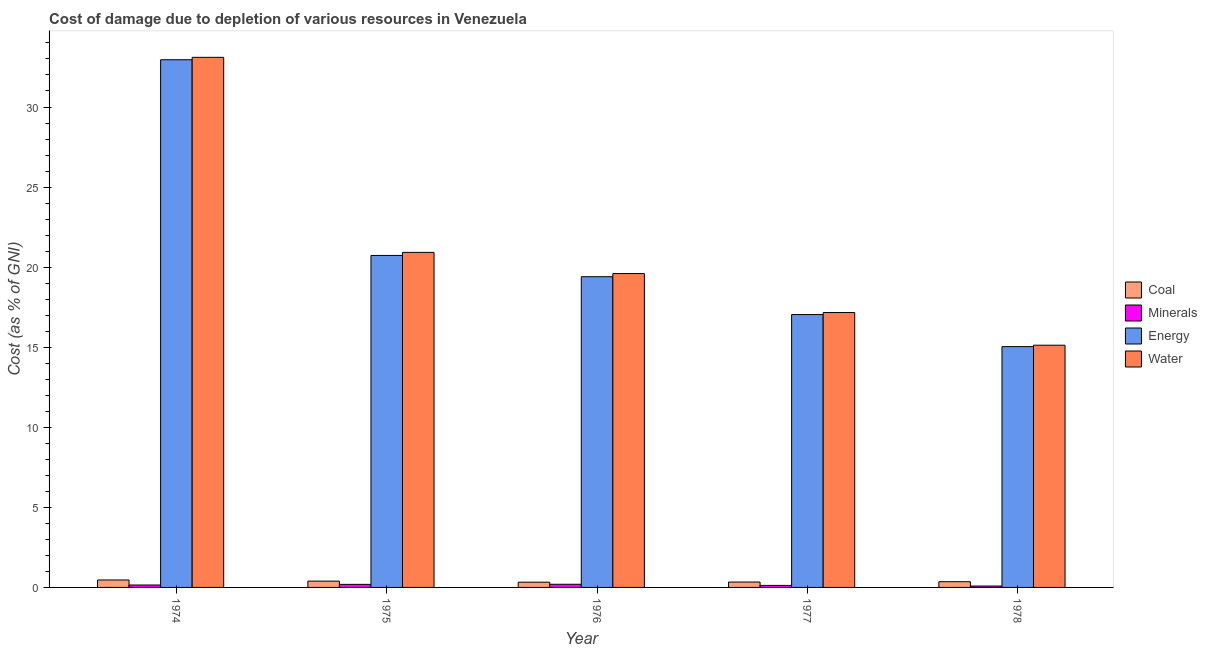How many different coloured bars are there?
Your answer should be very brief. 4. How many groups of bars are there?
Provide a succinct answer. 5. Are the number of bars per tick equal to the number of legend labels?
Offer a terse response. Yes. Are the number of bars on each tick of the X-axis equal?
Offer a terse response. Yes. How many bars are there on the 5th tick from the left?
Provide a short and direct response. 4. What is the label of the 1st group of bars from the left?
Provide a short and direct response. 1974. What is the cost of damage due to depletion of water in 1978?
Ensure brevity in your answer.  15.13. Across all years, what is the maximum cost of damage due to depletion of minerals?
Your response must be concise. 0.2. Across all years, what is the minimum cost of damage due to depletion of minerals?
Ensure brevity in your answer.  0.09. In which year was the cost of damage due to depletion of water maximum?
Ensure brevity in your answer.  1974. In which year was the cost of damage due to depletion of water minimum?
Your answer should be compact. 1978. What is the total cost of damage due to depletion of minerals in the graph?
Your answer should be very brief. 0.75. What is the difference between the cost of damage due to depletion of water in 1976 and that in 1978?
Your response must be concise. 4.47. What is the difference between the cost of damage due to depletion of coal in 1974 and the cost of damage due to depletion of minerals in 1978?
Your answer should be very brief. 0.11. What is the average cost of damage due to depletion of water per year?
Keep it short and to the point. 21.18. In the year 1974, what is the difference between the cost of damage due to depletion of minerals and cost of damage due to depletion of energy?
Ensure brevity in your answer.  0. What is the ratio of the cost of damage due to depletion of energy in 1976 to that in 1978?
Give a very brief answer. 1.29. Is the cost of damage due to depletion of coal in 1974 less than that in 1975?
Provide a short and direct response. No. What is the difference between the highest and the second highest cost of damage due to depletion of water?
Your response must be concise. 12.18. What is the difference between the highest and the lowest cost of damage due to depletion of water?
Offer a very short reply. 17.98. Is the sum of the cost of damage due to depletion of coal in 1975 and 1976 greater than the maximum cost of damage due to depletion of water across all years?
Give a very brief answer. Yes. What does the 2nd bar from the left in 1976 represents?
Offer a terse response. Minerals. What does the 3rd bar from the right in 1975 represents?
Provide a succinct answer. Minerals. Is it the case that in every year, the sum of the cost of damage due to depletion of coal and cost of damage due to depletion of minerals is greater than the cost of damage due to depletion of energy?
Your answer should be compact. No. How many bars are there?
Offer a very short reply. 20. Are all the bars in the graph horizontal?
Offer a terse response. No. How many years are there in the graph?
Make the answer very short. 5. Where does the legend appear in the graph?
Make the answer very short. Center right. How are the legend labels stacked?
Your response must be concise. Vertical. What is the title of the graph?
Provide a short and direct response. Cost of damage due to depletion of various resources in Venezuela . Does "Primary education" appear as one of the legend labels in the graph?
Make the answer very short. No. What is the label or title of the Y-axis?
Provide a succinct answer. Cost (as % of GNI). What is the Cost (as % of GNI) in Coal in 1974?
Make the answer very short. 0.47. What is the Cost (as % of GNI) in Minerals in 1974?
Offer a terse response. 0.15. What is the Cost (as % of GNI) in Energy in 1974?
Offer a very short reply. 32.95. What is the Cost (as % of GNI) in Water in 1974?
Make the answer very short. 33.1. What is the Cost (as % of GNI) in Coal in 1975?
Give a very brief answer. 0.39. What is the Cost (as % of GNI) in Minerals in 1975?
Make the answer very short. 0.19. What is the Cost (as % of GNI) in Energy in 1975?
Provide a succinct answer. 20.73. What is the Cost (as % of GNI) in Water in 1975?
Offer a very short reply. 20.92. What is the Cost (as % of GNI) in Coal in 1976?
Offer a very short reply. 0.33. What is the Cost (as % of GNI) of Minerals in 1976?
Give a very brief answer. 0.2. What is the Cost (as % of GNI) of Energy in 1976?
Provide a short and direct response. 19.4. What is the Cost (as % of GNI) of Water in 1976?
Your answer should be very brief. 19.6. What is the Cost (as % of GNI) of Coal in 1977?
Give a very brief answer. 0.34. What is the Cost (as % of GNI) in Minerals in 1977?
Give a very brief answer. 0.13. What is the Cost (as % of GNI) in Energy in 1977?
Provide a succinct answer. 17.04. What is the Cost (as % of GNI) in Water in 1977?
Offer a terse response. 17.17. What is the Cost (as % of GNI) in Coal in 1978?
Give a very brief answer. 0.36. What is the Cost (as % of GNI) of Minerals in 1978?
Give a very brief answer. 0.09. What is the Cost (as % of GNI) in Energy in 1978?
Keep it short and to the point. 15.04. What is the Cost (as % of GNI) in Water in 1978?
Offer a very short reply. 15.13. Across all years, what is the maximum Cost (as % of GNI) of Coal?
Make the answer very short. 0.47. Across all years, what is the maximum Cost (as % of GNI) of Minerals?
Your answer should be very brief. 0.2. Across all years, what is the maximum Cost (as % of GNI) in Energy?
Offer a very short reply. 32.95. Across all years, what is the maximum Cost (as % of GNI) in Water?
Your answer should be compact. 33.1. Across all years, what is the minimum Cost (as % of GNI) of Coal?
Provide a short and direct response. 0.33. Across all years, what is the minimum Cost (as % of GNI) in Minerals?
Your response must be concise. 0.09. Across all years, what is the minimum Cost (as % of GNI) in Energy?
Keep it short and to the point. 15.04. Across all years, what is the minimum Cost (as % of GNI) of Water?
Offer a terse response. 15.13. What is the total Cost (as % of GNI) of Coal in the graph?
Offer a very short reply. 1.88. What is the total Cost (as % of GNI) in Minerals in the graph?
Offer a terse response. 0.75. What is the total Cost (as % of GNI) of Energy in the graph?
Your response must be concise. 105.16. What is the total Cost (as % of GNI) in Water in the graph?
Make the answer very short. 105.91. What is the difference between the Cost (as % of GNI) of Coal in 1974 and that in 1975?
Provide a succinct answer. 0.07. What is the difference between the Cost (as % of GNI) of Minerals in 1974 and that in 1975?
Keep it short and to the point. -0.04. What is the difference between the Cost (as % of GNI) in Energy in 1974 and that in 1975?
Provide a short and direct response. 12.22. What is the difference between the Cost (as % of GNI) in Water in 1974 and that in 1975?
Your answer should be very brief. 12.18. What is the difference between the Cost (as % of GNI) in Coal in 1974 and that in 1976?
Offer a terse response. 0.14. What is the difference between the Cost (as % of GNI) of Minerals in 1974 and that in 1976?
Your answer should be very brief. -0.05. What is the difference between the Cost (as % of GNI) of Energy in 1974 and that in 1976?
Ensure brevity in your answer.  13.55. What is the difference between the Cost (as % of GNI) in Water in 1974 and that in 1976?
Keep it short and to the point. 13.5. What is the difference between the Cost (as % of GNI) in Coal in 1974 and that in 1977?
Ensure brevity in your answer.  0.13. What is the difference between the Cost (as % of GNI) in Minerals in 1974 and that in 1977?
Provide a short and direct response. 0.02. What is the difference between the Cost (as % of GNI) in Energy in 1974 and that in 1977?
Your response must be concise. 15.91. What is the difference between the Cost (as % of GNI) of Water in 1974 and that in 1977?
Keep it short and to the point. 15.94. What is the difference between the Cost (as % of GNI) in Coal in 1974 and that in 1978?
Your answer should be very brief. 0.11. What is the difference between the Cost (as % of GNI) of Minerals in 1974 and that in 1978?
Offer a terse response. 0.06. What is the difference between the Cost (as % of GNI) of Energy in 1974 and that in 1978?
Ensure brevity in your answer.  17.91. What is the difference between the Cost (as % of GNI) in Water in 1974 and that in 1978?
Make the answer very short. 17.98. What is the difference between the Cost (as % of GNI) in Coal in 1975 and that in 1976?
Give a very brief answer. 0.07. What is the difference between the Cost (as % of GNI) in Minerals in 1975 and that in 1976?
Give a very brief answer. -0.01. What is the difference between the Cost (as % of GNI) of Energy in 1975 and that in 1976?
Offer a terse response. 1.33. What is the difference between the Cost (as % of GNI) of Water in 1975 and that in 1976?
Give a very brief answer. 1.32. What is the difference between the Cost (as % of GNI) of Coal in 1975 and that in 1977?
Provide a short and direct response. 0.06. What is the difference between the Cost (as % of GNI) of Minerals in 1975 and that in 1977?
Make the answer very short. 0.06. What is the difference between the Cost (as % of GNI) in Energy in 1975 and that in 1977?
Give a very brief answer. 3.69. What is the difference between the Cost (as % of GNI) in Water in 1975 and that in 1977?
Your response must be concise. 3.76. What is the difference between the Cost (as % of GNI) in Coal in 1975 and that in 1978?
Keep it short and to the point. 0.04. What is the difference between the Cost (as % of GNI) in Minerals in 1975 and that in 1978?
Your answer should be very brief. 0.1. What is the difference between the Cost (as % of GNI) of Energy in 1975 and that in 1978?
Give a very brief answer. 5.69. What is the difference between the Cost (as % of GNI) of Water in 1975 and that in 1978?
Your answer should be very brief. 5.8. What is the difference between the Cost (as % of GNI) of Coal in 1976 and that in 1977?
Give a very brief answer. -0.01. What is the difference between the Cost (as % of GNI) of Minerals in 1976 and that in 1977?
Provide a short and direct response. 0.07. What is the difference between the Cost (as % of GNI) in Energy in 1976 and that in 1977?
Give a very brief answer. 2.36. What is the difference between the Cost (as % of GNI) in Water in 1976 and that in 1977?
Keep it short and to the point. 2.43. What is the difference between the Cost (as % of GNI) in Coal in 1976 and that in 1978?
Ensure brevity in your answer.  -0.03. What is the difference between the Cost (as % of GNI) of Minerals in 1976 and that in 1978?
Offer a very short reply. 0.11. What is the difference between the Cost (as % of GNI) in Energy in 1976 and that in 1978?
Offer a terse response. 4.37. What is the difference between the Cost (as % of GNI) of Water in 1976 and that in 1978?
Your answer should be very brief. 4.47. What is the difference between the Cost (as % of GNI) in Coal in 1977 and that in 1978?
Your response must be concise. -0.02. What is the difference between the Cost (as % of GNI) of Minerals in 1977 and that in 1978?
Provide a short and direct response. 0.04. What is the difference between the Cost (as % of GNI) in Energy in 1977 and that in 1978?
Your response must be concise. 2. What is the difference between the Cost (as % of GNI) in Water in 1977 and that in 1978?
Give a very brief answer. 2.04. What is the difference between the Cost (as % of GNI) of Coal in 1974 and the Cost (as % of GNI) of Minerals in 1975?
Give a very brief answer. 0.27. What is the difference between the Cost (as % of GNI) of Coal in 1974 and the Cost (as % of GNI) of Energy in 1975?
Provide a succinct answer. -20.27. What is the difference between the Cost (as % of GNI) in Coal in 1974 and the Cost (as % of GNI) in Water in 1975?
Provide a succinct answer. -20.46. What is the difference between the Cost (as % of GNI) of Minerals in 1974 and the Cost (as % of GNI) of Energy in 1975?
Provide a succinct answer. -20.58. What is the difference between the Cost (as % of GNI) in Minerals in 1974 and the Cost (as % of GNI) in Water in 1975?
Your answer should be compact. -20.77. What is the difference between the Cost (as % of GNI) in Energy in 1974 and the Cost (as % of GNI) in Water in 1975?
Provide a succinct answer. 12.03. What is the difference between the Cost (as % of GNI) of Coal in 1974 and the Cost (as % of GNI) of Minerals in 1976?
Offer a very short reply. 0.27. What is the difference between the Cost (as % of GNI) in Coal in 1974 and the Cost (as % of GNI) in Energy in 1976?
Provide a short and direct response. -18.94. What is the difference between the Cost (as % of GNI) of Coal in 1974 and the Cost (as % of GNI) of Water in 1976?
Ensure brevity in your answer.  -19.13. What is the difference between the Cost (as % of GNI) of Minerals in 1974 and the Cost (as % of GNI) of Energy in 1976?
Ensure brevity in your answer.  -19.25. What is the difference between the Cost (as % of GNI) of Minerals in 1974 and the Cost (as % of GNI) of Water in 1976?
Offer a terse response. -19.45. What is the difference between the Cost (as % of GNI) of Energy in 1974 and the Cost (as % of GNI) of Water in 1976?
Give a very brief answer. 13.35. What is the difference between the Cost (as % of GNI) in Coal in 1974 and the Cost (as % of GNI) in Minerals in 1977?
Keep it short and to the point. 0.34. What is the difference between the Cost (as % of GNI) of Coal in 1974 and the Cost (as % of GNI) of Energy in 1977?
Ensure brevity in your answer.  -16.57. What is the difference between the Cost (as % of GNI) in Coal in 1974 and the Cost (as % of GNI) in Water in 1977?
Provide a short and direct response. -16.7. What is the difference between the Cost (as % of GNI) in Minerals in 1974 and the Cost (as % of GNI) in Energy in 1977?
Your response must be concise. -16.89. What is the difference between the Cost (as % of GNI) of Minerals in 1974 and the Cost (as % of GNI) of Water in 1977?
Ensure brevity in your answer.  -17.01. What is the difference between the Cost (as % of GNI) in Energy in 1974 and the Cost (as % of GNI) in Water in 1977?
Keep it short and to the point. 15.79. What is the difference between the Cost (as % of GNI) in Coal in 1974 and the Cost (as % of GNI) in Minerals in 1978?
Your answer should be very brief. 0.38. What is the difference between the Cost (as % of GNI) in Coal in 1974 and the Cost (as % of GNI) in Energy in 1978?
Make the answer very short. -14.57. What is the difference between the Cost (as % of GNI) in Coal in 1974 and the Cost (as % of GNI) in Water in 1978?
Ensure brevity in your answer.  -14.66. What is the difference between the Cost (as % of GNI) in Minerals in 1974 and the Cost (as % of GNI) in Energy in 1978?
Offer a very short reply. -14.89. What is the difference between the Cost (as % of GNI) in Minerals in 1974 and the Cost (as % of GNI) in Water in 1978?
Offer a very short reply. -14.97. What is the difference between the Cost (as % of GNI) of Energy in 1974 and the Cost (as % of GNI) of Water in 1978?
Your response must be concise. 17.83. What is the difference between the Cost (as % of GNI) in Coal in 1975 and the Cost (as % of GNI) in Minerals in 1976?
Make the answer very short. 0.2. What is the difference between the Cost (as % of GNI) of Coal in 1975 and the Cost (as % of GNI) of Energy in 1976?
Provide a short and direct response. -19.01. What is the difference between the Cost (as % of GNI) in Coal in 1975 and the Cost (as % of GNI) in Water in 1976?
Give a very brief answer. -19.21. What is the difference between the Cost (as % of GNI) of Minerals in 1975 and the Cost (as % of GNI) of Energy in 1976?
Provide a succinct answer. -19.21. What is the difference between the Cost (as % of GNI) in Minerals in 1975 and the Cost (as % of GNI) in Water in 1976?
Your answer should be very brief. -19.41. What is the difference between the Cost (as % of GNI) of Energy in 1975 and the Cost (as % of GNI) of Water in 1976?
Your answer should be compact. 1.13. What is the difference between the Cost (as % of GNI) in Coal in 1975 and the Cost (as % of GNI) in Minerals in 1977?
Provide a short and direct response. 0.27. What is the difference between the Cost (as % of GNI) in Coal in 1975 and the Cost (as % of GNI) in Energy in 1977?
Offer a terse response. -16.64. What is the difference between the Cost (as % of GNI) in Coal in 1975 and the Cost (as % of GNI) in Water in 1977?
Your answer should be very brief. -16.77. What is the difference between the Cost (as % of GNI) of Minerals in 1975 and the Cost (as % of GNI) of Energy in 1977?
Ensure brevity in your answer.  -16.85. What is the difference between the Cost (as % of GNI) of Minerals in 1975 and the Cost (as % of GNI) of Water in 1977?
Provide a succinct answer. -16.97. What is the difference between the Cost (as % of GNI) in Energy in 1975 and the Cost (as % of GNI) in Water in 1977?
Your answer should be compact. 3.57. What is the difference between the Cost (as % of GNI) of Coal in 1975 and the Cost (as % of GNI) of Minerals in 1978?
Keep it short and to the point. 0.31. What is the difference between the Cost (as % of GNI) of Coal in 1975 and the Cost (as % of GNI) of Energy in 1978?
Your answer should be very brief. -14.64. What is the difference between the Cost (as % of GNI) of Coal in 1975 and the Cost (as % of GNI) of Water in 1978?
Offer a very short reply. -14.73. What is the difference between the Cost (as % of GNI) in Minerals in 1975 and the Cost (as % of GNI) in Energy in 1978?
Offer a terse response. -14.85. What is the difference between the Cost (as % of GNI) in Minerals in 1975 and the Cost (as % of GNI) in Water in 1978?
Keep it short and to the point. -14.93. What is the difference between the Cost (as % of GNI) of Energy in 1975 and the Cost (as % of GNI) of Water in 1978?
Provide a succinct answer. 5.61. What is the difference between the Cost (as % of GNI) of Coal in 1976 and the Cost (as % of GNI) of Minerals in 1977?
Ensure brevity in your answer.  0.2. What is the difference between the Cost (as % of GNI) of Coal in 1976 and the Cost (as % of GNI) of Energy in 1977?
Provide a short and direct response. -16.71. What is the difference between the Cost (as % of GNI) of Coal in 1976 and the Cost (as % of GNI) of Water in 1977?
Offer a very short reply. -16.84. What is the difference between the Cost (as % of GNI) of Minerals in 1976 and the Cost (as % of GNI) of Energy in 1977?
Keep it short and to the point. -16.84. What is the difference between the Cost (as % of GNI) in Minerals in 1976 and the Cost (as % of GNI) in Water in 1977?
Provide a short and direct response. -16.97. What is the difference between the Cost (as % of GNI) in Energy in 1976 and the Cost (as % of GNI) in Water in 1977?
Ensure brevity in your answer.  2.24. What is the difference between the Cost (as % of GNI) in Coal in 1976 and the Cost (as % of GNI) in Minerals in 1978?
Ensure brevity in your answer.  0.24. What is the difference between the Cost (as % of GNI) of Coal in 1976 and the Cost (as % of GNI) of Energy in 1978?
Ensure brevity in your answer.  -14.71. What is the difference between the Cost (as % of GNI) of Coal in 1976 and the Cost (as % of GNI) of Water in 1978?
Give a very brief answer. -14.8. What is the difference between the Cost (as % of GNI) of Minerals in 1976 and the Cost (as % of GNI) of Energy in 1978?
Keep it short and to the point. -14.84. What is the difference between the Cost (as % of GNI) in Minerals in 1976 and the Cost (as % of GNI) in Water in 1978?
Your answer should be compact. -14.93. What is the difference between the Cost (as % of GNI) of Energy in 1976 and the Cost (as % of GNI) of Water in 1978?
Provide a succinct answer. 4.28. What is the difference between the Cost (as % of GNI) of Coal in 1977 and the Cost (as % of GNI) of Minerals in 1978?
Give a very brief answer. 0.25. What is the difference between the Cost (as % of GNI) of Coal in 1977 and the Cost (as % of GNI) of Energy in 1978?
Provide a succinct answer. -14.7. What is the difference between the Cost (as % of GNI) of Coal in 1977 and the Cost (as % of GNI) of Water in 1978?
Ensure brevity in your answer.  -14.79. What is the difference between the Cost (as % of GNI) in Minerals in 1977 and the Cost (as % of GNI) in Energy in 1978?
Offer a terse response. -14.91. What is the difference between the Cost (as % of GNI) in Minerals in 1977 and the Cost (as % of GNI) in Water in 1978?
Make the answer very short. -15. What is the difference between the Cost (as % of GNI) of Energy in 1977 and the Cost (as % of GNI) of Water in 1978?
Provide a short and direct response. 1.91. What is the average Cost (as % of GNI) in Coal per year?
Your answer should be very brief. 0.38. What is the average Cost (as % of GNI) in Minerals per year?
Ensure brevity in your answer.  0.15. What is the average Cost (as % of GNI) in Energy per year?
Ensure brevity in your answer.  21.03. What is the average Cost (as % of GNI) of Water per year?
Ensure brevity in your answer.  21.18. In the year 1974, what is the difference between the Cost (as % of GNI) of Coal and Cost (as % of GNI) of Minerals?
Provide a short and direct response. 0.31. In the year 1974, what is the difference between the Cost (as % of GNI) in Coal and Cost (as % of GNI) in Energy?
Ensure brevity in your answer.  -32.49. In the year 1974, what is the difference between the Cost (as % of GNI) in Coal and Cost (as % of GNI) in Water?
Provide a succinct answer. -32.64. In the year 1974, what is the difference between the Cost (as % of GNI) of Minerals and Cost (as % of GNI) of Energy?
Give a very brief answer. -32.8. In the year 1974, what is the difference between the Cost (as % of GNI) of Minerals and Cost (as % of GNI) of Water?
Your answer should be compact. -32.95. In the year 1974, what is the difference between the Cost (as % of GNI) of Energy and Cost (as % of GNI) of Water?
Make the answer very short. -0.15. In the year 1975, what is the difference between the Cost (as % of GNI) in Coal and Cost (as % of GNI) in Minerals?
Ensure brevity in your answer.  0.2. In the year 1975, what is the difference between the Cost (as % of GNI) of Coal and Cost (as % of GNI) of Energy?
Offer a terse response. -20.34. In the year 1975, what is the difference between the Cost (as % of GNI) in Coal and Cost (as % of GNI) in Water?
Your response must be concise. -20.53. In the year 1975, what is the difference between the Cost (as % of GNI) in Minerals and Cost (as % of GNI) in Energy?
Offer a terse response. -20.54. In the year 1975, what is the difference between the Cost (as % of GNI) in Minerals and Cost (as % of GNI) in Water?
Ensure brevity in your answer.  -20.73. In the year 1975, what is the difference between the Cost (as % of GNI) in Energy and Cost (as % of GNI) in Water?
Make the answer very short. -0.19. In the year 1976, what is the difference between the Cost (as % of GNI) in Coal and Cost (as % of GNI) in Minerals?
Your response must be concise. 0.13. In the year 1976, what is the difference between the Cost (as % of GNI) of Coal and Cost (as % of GNI) of Energy?
Provide a succinct answer. -19.08. In the year 1976, what is the difference between the Cost (as % of GNI) of Coal and Cost (as % of GNI) of Water?
Your answer should be compact. -19.27. In the year 1976, what is the difference between the Cost (as % of GNI) of Minerals and Cost (as % of GNI) of Energy?
Offer a very short reply. -19.21. In the year 1976, what is the difference between the Cost (as % of GNI) in Minerals and Cost (as % of GNI) in Water?
Provide a succinct answer. -19.4. In the year 1976, what is the difference between the Cost (as % of GNI) in Energy and Cost (as % of GNI) in Water?
Your answer should be very brief. -0.2. In the year 1977, what is the difference between the Cost (as % of GNI) of Coal and Cost (as % of GNI) of Minerals?
Your response must be concise. 0.21. In the year 1977, what is the difference between the Cost (as % of GNI) of Coal and Cost (as % of GNI) of Energy?
Give a very brief answer. -16.7. In the year 1977, what is the difference between the Cost (as % of GNI) in Coal and Cost (as % of GNI) in Water?
Give a very brief answer. -16.83. In the year 1977, what is the difference between the Cost (as % of GNI) in Minerals and Cost (as % of GNI) in Energy?
Offer a terse response. -16.91. In the year 1977, what is the difference between the Cost (as % of GNI) in Minerals and Cost (as % of GNI) in Water?
Provide a succinct answer. -17.04. In the year 1977, what is the difference between the Cost (as % of GNI) in Energy and Cost (as % of GNI) in Water?
Provide a short and direct response. -0.13. In the year 1978, what is the difference between the Cost (as % of GNI) of Coal and Cost (as % of GNI) of Minerals?
Your answer should be compact. 0.27. In the year 1978, what is the difference between the Cost (as % of GNI) in Coal and Cost (as % of GNI) in Energy?
Provide a succinct answer. -14.68. In the year 1978, what is the difference between the Cost (as % of GNI) of Coal and Cost (as % of GNI) of Water?
Keep it short and to the point. -14.77. In the year 1978, what is the difference between the Cost (as % of GNI) in Minerals and Cost (as % of GNI) in Energy?
Provide a short and direct response. -14.95. In the year 1978, what is the difference between the Cost (as % of GNI) of Minerals and Cost (as % of GNI) of Water?
Make the answer very short. -15.04. In the year 1978, what is the difference between the Cost (as % of GNI) of Energy and Cost (as % of GNI) of Water?
Provide a short and direct response. -0.09. What is the ratio of the Cost (as % of GNI) of Coal in 1974 to that in 1975?
Your answer should be very brief. 1.18. What is the ratio of the Cost (as % of GNI) in Minerals in 1974 to that in 1975?
Your answer should be compact. 0.79. What is the ratio of the Cost (as % of GNI) of Energy in 1974 to that in 1975?
Keep it short and to the point. 1.59. What is the ratio of the Cost (as % of GNI) in Water in 1974 to that in 1975?
Offer a very short reply. 1.58. What is the ratio of the Cost (as % of GNI) of Coal in 1974 to that in 1976?
Your answer should be very brief. 1.42. What is the ratio of the Cost (as % of GNI) in Minerals in 1974 to that in 1976?
Offer a terse response. 0.77. What is the ratio of the Cost (as % of GNI) in Energy in 1974 to that in 1976?
Your answer should be very brief. 1.7. What is the ratio of the Cost (as % of GNI) of Water in 1974 to that in 1976?
Your answer should be very brief. 1.69. What is the ratio of the Cost (as % of GNI) in Coal in 1974 to that in 1977?
Offer a very short reply. 1.39. What is the ratio of the Cost (as % of GNI) of Minerals in 1974 to that in 1977?
Ensure brevity in your answer.  1.19. What is the ratio of the Cost (as % of GNI) in Energy in 1974 to that in 1977?
Your response must be concise. 1.93. What is the ratio of the Cost (as % of GNI) of Water in 1974 to that in 1977?
Your answer should be very brief. 1.93. What is the ratio of the Cost (as % of GNI) of Coal in 1974 to that in 1978?
Make the answer very short. 1.3. What is the ratio of the Cost (as % of GNI) in Minerals in 1974 to that in 1978?
Offer a very short reply. 1.72. What is the ratio of the Cost (as % of GNI) in Energy in 1974 to that in 1978?
Your response must be concise. 2.19. What is the ratio of the Cost (as % of GNI) in Water in 1974 to that in 1978?
Offer a terse response. 2.19. What is the ratio of the Cost (as % of GNI) of Coal in 1975 to that in 1976?
Your answer should be very brief. 1.21. What is the ratio of the Cost (as % of GNI) of Minerals in 1975 to that in 1976?
Offer a terse response. 0.97. What is the ratio of the Cost (as % of GNI) in Energy in 1975 to that in 1976?
Your response must be concise. 1.07. What is the ratio of the Cost (as % of GNI) in Water in 1975 to that in 1976?
Offer a very short reply. 1.07. What is the ratio of the Cost (as % of GNI) in Coal in 1975 to that in 1977?
Your response must be concise. 1.18. What is the ratio of the Cost (as % of GNI) of Minerals in 1975 to that in 1977?
Offer a terse response. 1.51. What is the ratio of the Cost (as % of GNI) in Energy in 1975 to that in 1977?
Your response must be concise. 1.22. What is the ratio of the Cost (as % of GNI) of Water in 1975 to that in 1977?
Offer a terse response. 1.22. What is the ratio of the Cost (as % of GNI) of Coal in 1975 to that in 1978?
Give a very brief answer. 1.11. What is the ratio of the Cost (as % of GNI) in Minerals in 1975 to that in 1978?
Your answer should be very brief. 2.18. What is the ratio of the Cost (as % of GNI) of Energy in 1975 to that in 1978?
Give a very brief answer. 1.38. What is the ratio of the Cost (as % of GNI) in Water in 1975 to that in 1978?
Your answer should be compact. 1.38. What is the ratio of the Cost (as % of GNI) of Coal in 1976 to that in 1977?
Ensure brevity in your answer.  0.97. What is the ratio of the Cost (as % of GNI) in Minerals in 1976 to that in 1977?
Your answer should be very brief. 1.56. What is the ratio of the Cost (as % of GNI) in Energy in 1976 to that in 1977?
Keep it short and to the point. 1.14. What is the ratio of the Cost (as % of GNI) of Water in 1976 to that in 1977?
Ensure brevity in your answer.  1.14. What is the ratio of the Cost (as % of GNI) in Coal in 1976 to that in 1978?
Offer a terse response. 0.92. What is the ratio of the Cost (as % of GNI) of Minerals in 1976 to that in 1978?
Ensure brevity in your answer.  2.24. What is the ratio of the Cost (as % of GNI) in Energy in 1976 to that in 1978?
Your answer should be very brief. 1.29. What is the ratio of the Cost (as % of GNI) in Water in 1976 to that in 1978?
Your response must be concise. 1.3. What is the ratio of the Cost (as % of GNI) of Coal in 1977 to that in 1978?
Provide a succinct answer. 0.94. What is the ratio of the Cost (as % of GNI) in Minerals in 1977 to that in 1978?
Provide a short and direct response. 1.44. What is the ratio of the Cost (as % of GNI) in Energy in 1977 to that in 1978?
Provide a short and direct response. 1.13. What is the ratio of the Cost (as % of GNI) of Water in 1977 to that in 1978?
Make the answer very short. 1.13. What is the difference between the highest and the second highest Cost (as % of GNI) of Coal?
Your response must be concise. 0.07. What is the difference between the highest and the second highest Cost (as % of GNI) in Minerals?
Your response must be concise. 0.01. What is the difference between the highest and the second highest Cost (as % of GNI) of Energy?
Make the answer very short. 12.22. What is the difference between the highest and the second highest Cost (as % of GNI) of Water?
Your response must be concise. 12.18. What is the difference between the highest and the lowest Cost (as % of GNI) of Coal?
Provide a short and direct response. 0.14. What is the difference between the highest and the lowest Cost (as % of GNI) of Minerals?
Give a very brief answer. 0.11. What is the difference between the highest and the lowest Cost (as % of GNI) of Energy?
Offer a terse response. 17.91. What is the difference between the highest and the lowest Cost (as % of GNI) in Water?
Offer a very short reply. 17.98. 